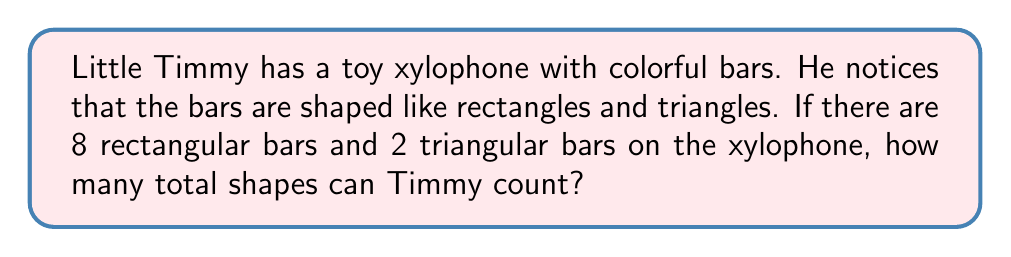Could you help me with this problem? Let's break this down step-by-step:

1. First, we need to identify the shapes Timmy sees on his xylophone:
   - Rectangular bars
   - Triangular bars

2. Now, let's count each shape:
   - Number of rectangular bars: 8
   - Number of triangular bars: 2

3. To find the total number of shapes, we need to add these together:
   
   $$ \text{Total shapes} = \text{Rectangles} + \text{Triangles} $$
   $$ \text{Total shapes} = 8 + 2 $$
   $$ \text{Total shapes} = 10 $$

So, Timmy can count a total of 10 shapes on his toy xylophone.
Answer: 10 shapes 